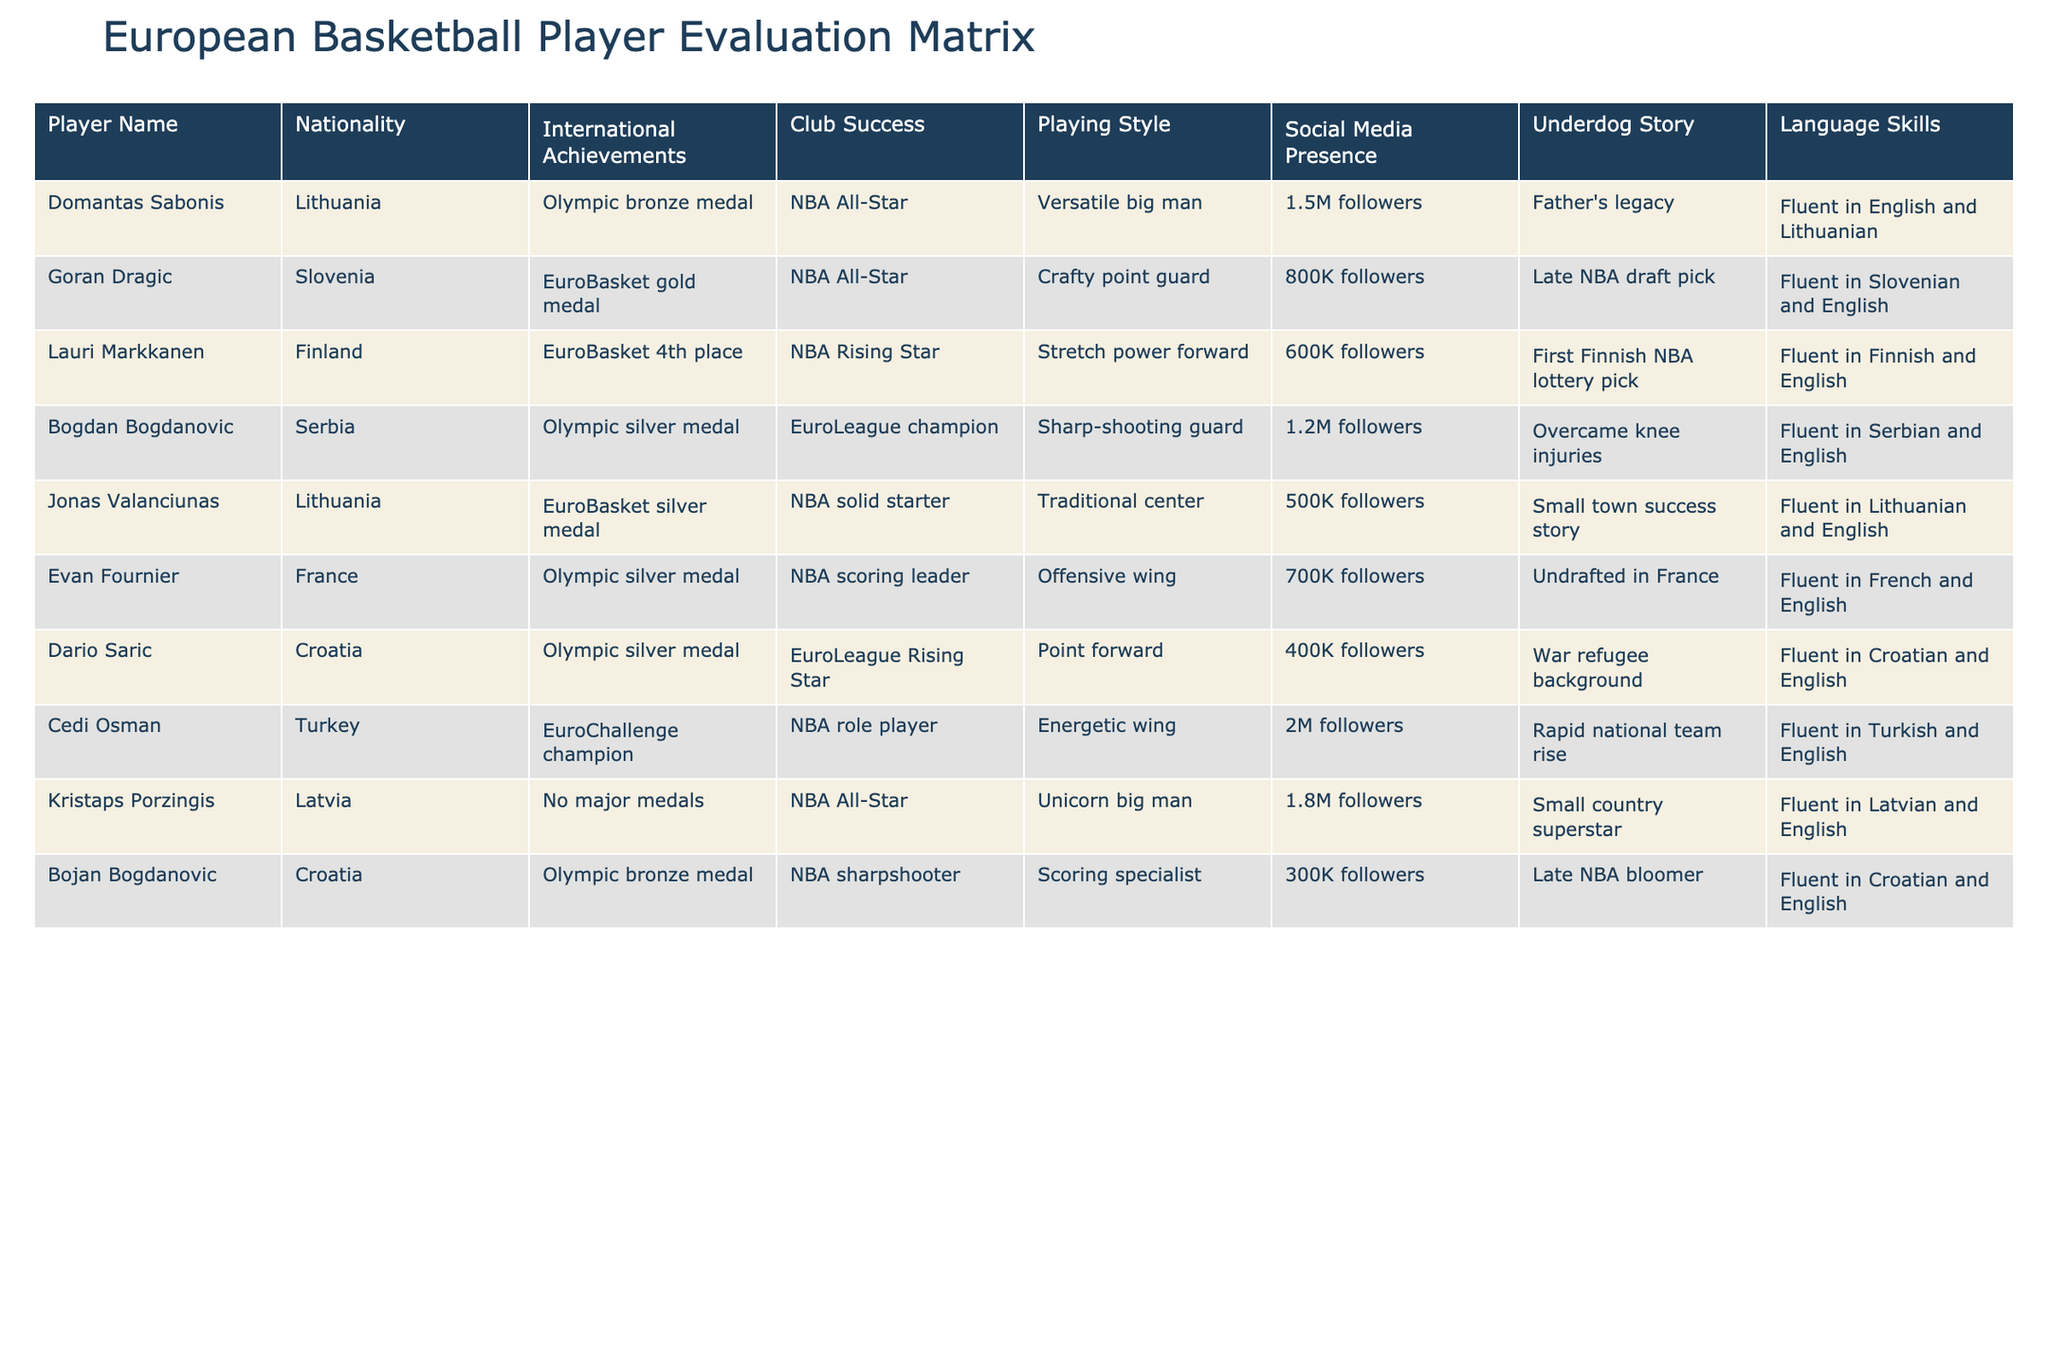What is the nationality of Goran Dragic? Goran Dragic is listed in the table as being from Slovenia. We can identify his nationality directly from the "Nationality" column corresponding to his name.
Answer: Slovenia How many social media followers does Cedi Osman have? Cedi Osman has 2 million followers according to the "Social Media Presence" column in the table. This value is clearly listed next to his name.
Answer: 2 million Which player has the most international achievements? Players like Domantas Sabonis and Goran Dragic have notable international achievements listed, but Bogdan Bogdanovic also has achievements such as Olympic silver medal and EuroLeague champion. However, since Sabonis and Dragic have significant accolades as well, we need to clarify they all have a prestigious recognition. Among them, Bogdan Bogdanovic’s achievements are high as well. So, this question might be subjective, but an argument can be made.
Answer: It's subjective based on achievements Which nationality has the least successful international achievement listed? Looking through the "International Achievements," we notice that Lauri Markkanen from Finland, who has 4th place at EuroBasket, may not be considered as successful when compared to players with medals. Hence, we conclude that Finland could be seen as less successful in terms of international achievements.
Answer: Finland Is there a player who has a significant presence on social media and has an underdog story? Yes, Cedi Osman has 2 million followers and is described as having a rapid national team rise, making him an underdog story. This matches both criteria from the "Social Media Presence" and "Underdog Story" columns.
Answer: Yes What is the total number of followers of players from Lithuania? The players from Lithuania in the table are Domantas Sabonis and Jonas Valanciunas. Sabonis has 1.5 million followers, and Valanciunas has 500K followers. Therefore, we sum these numbers: 1.5 million + 0.5 million = 2 million.
Answer: 2 million Which player has a language skill in a language that is not among the most widely spoken in the world? Dario Saric is fluent in Croatian, which may not be as widely spoken globally compared to languages like English or French. Evaluating the language skills listed, Croatian is not among the most widely spoken.
Answer: Dario Saric Which players are fluent in English besides Goran Dragic? The players who are fluent in English in addition to Goran Dragic are Domantas Sabonis, Lauri Markkanen, Bogdan Bogdanovic, Jonas Valanciunas, Evan Fournier, Dario Saric, Cedi Osman, Kristaps Porzingis, and Bojan Bogdanovic. They all have "Fluent in English" listed next to their names. Counting these will give us a total of 9 players fluent in English.
Answer: 9 players 